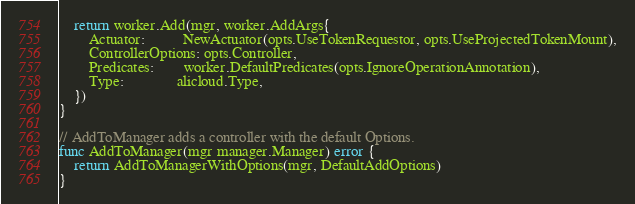<code> <loc_0><loc_0><loc_500><loc_500><_Go_>
	return worker.Add(mgr, worker.AddArgs{
		Actuator:          NewActuator(opts.UseTokenRequestor, opts.UseProjectedTokenMount),
		ControllerOptions: opts.Controller,
		Predicates:        worker.DefaultPredicates(opts.IgnoreOperationAnnotation),
		Type:              alicloud.Type,
	})
}

// AddToManager adds a controller with the default Options.
func AddToManager(mgr manager.Manager) error {
	return AddToManagerWithOptions(mgr, DefaultAddOptions)
}
</code> 